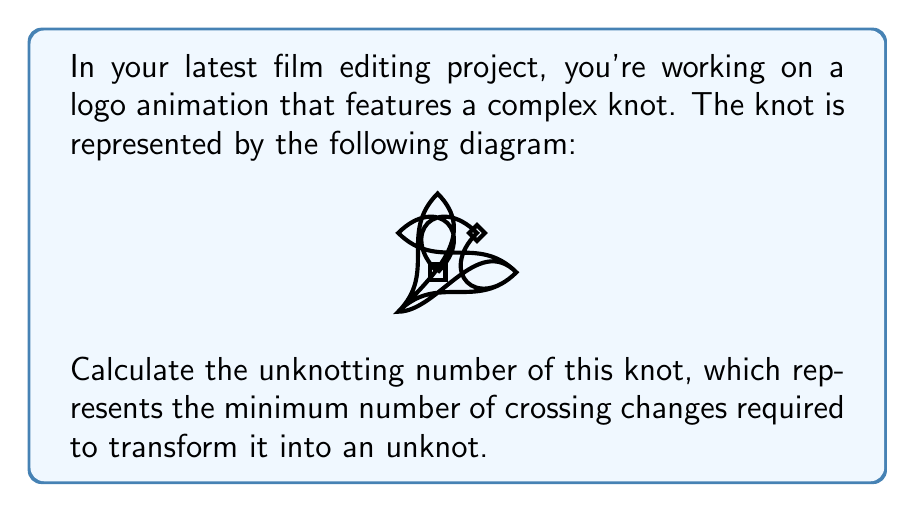Help me with this question. To solve this problem, we'll follow these steps:

1) First, we need to identify the knot type. The given diagram represents a figure-eight knot, which is one of the simplest non-trivial knots.

2) The unknotting number of a knot is the minimum number of crossing changes required to transform it into an unknot (also known as the trivial knot).

3) For the figure-eight knot, it's known that the unknotting number is 1. This means we only need to change one crossing to unknot it.

4) To visualize this, we can change one of the crossings in the diagram:

   [asy]
   import graph;
   size(200);
   pen p = linewidth(1.5);
   
   path knot = (0,0)..(-0.5,0.5)..(0,1)..(0.5,0.5)..(0,0)..(0.5,-0.5)..(1,0)..(0.5,0.5)..(0,-0.5)..(-0.5,-0.5)..(0,0);
   
   draw(knot, p);
   draw((0.1,0.1)--(0.1,-0.1)--(-0.1,-0.1)--(-0.1,0.1)--cycle, p);
   draw((0.5,0.4)--(0.6,0.5)--(0.5,0.6)--(0.4,0.5)--cycle, p);
   [/asy]

5) After this single crossing change, the knot can be deformed into a simple loop, which is the unknot.

6) It's important to note that no fewer crossing changes can unknot the figure-eight knot. This is proven rigorously using various knot invariants, such as the Jones polynomial.

Therefore, the unknotting number of the figure-eight knot in your logo animation is 1.
Answer: 1 